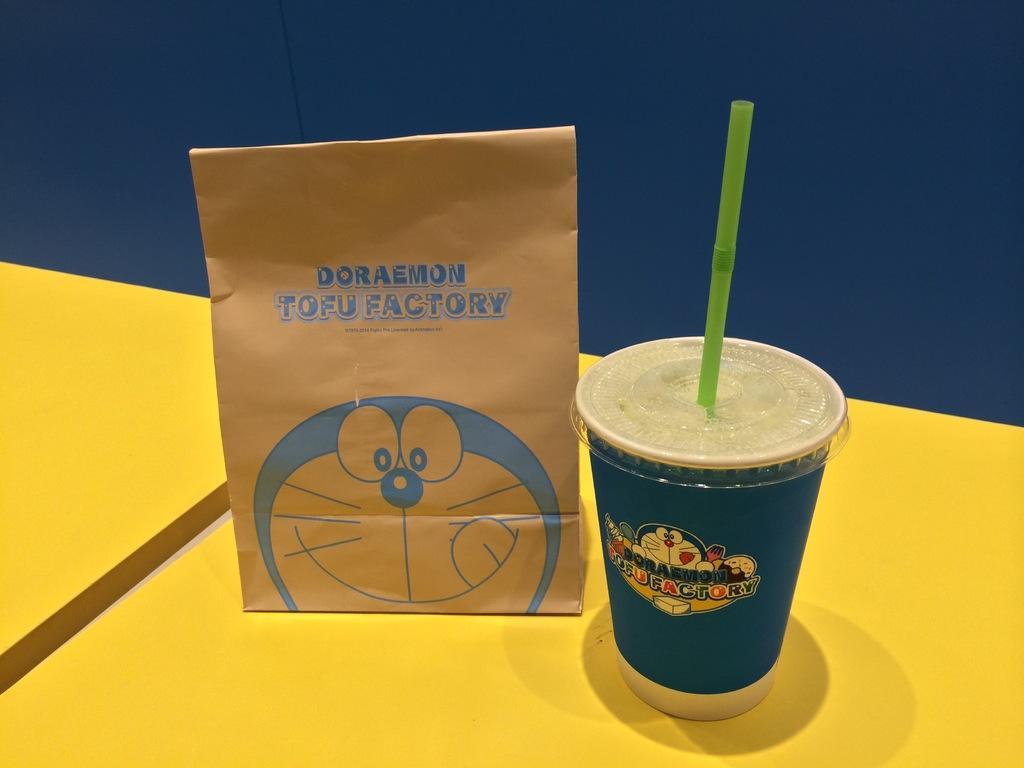How would you summarize this image in a sentence or two? In the picture we can see a part of the yellow color table, on it we can see the glass with a drink and straw in it and beside it, we can see cover parcel and behind it we can see the wall which is blue in color. 